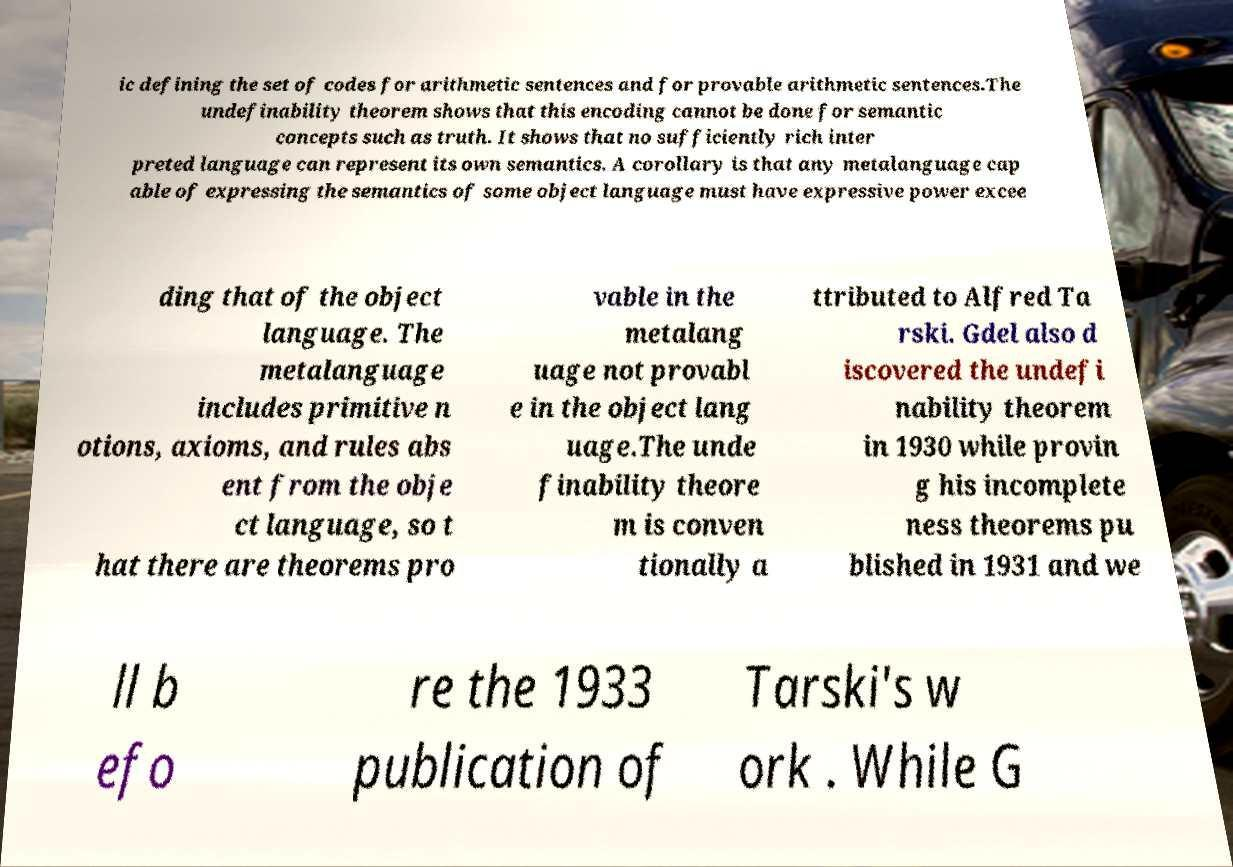Please identify and transcribe the text found in this image. ic defining the set of codes for arithmetic sentences and for provable arithmetic sentences.The undefinability theorem shows that this encoding cannot be done for semantic concepts such as truth. It shows that no sufficiently rich inter preted language can represent its own semantics. A corollary is that any metalanguage cap able of expressing the semantics of some object language must have expressive power excee ding that of the object language. The metalanguage includes primitive n otions, axioms, and rules abs ent from the obje ct language, so t hat there are theorems pro vable in the metalang uage not provabl e in the object lang uage.The unde finability theore m is conven tionally a ttributed to Alfred Ta rski. Gdel also d iscovered the undefi nability theorem in 1930 while provin g his incomplete ness theorems pu blished in 1931 and we ll b efo re the 1933 publication of Tarski's w ork . While G 